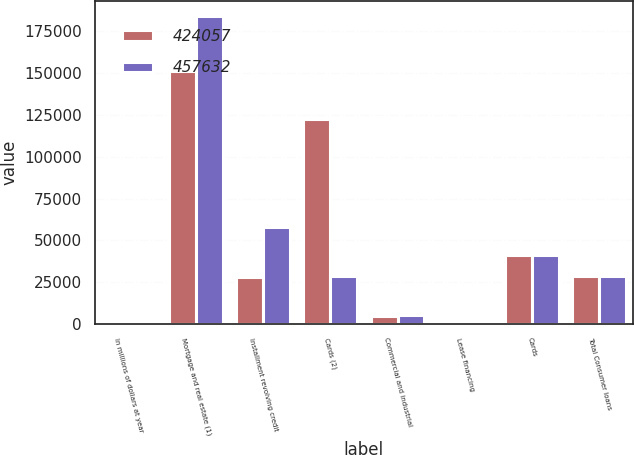Convert chart to OTSL. <chart><loc_0><loc_0><loc_500><loc_500><stacked_bar_chart><ecel><fcel>In millions of dollars at year<fcel>Mortgage and real estate (1)<fcel>Installment revolving credit<fcel>Cards (2)<fcel>Commercial and industrial<fcel>Lease financing<fcel>Cards<fcel>Total Consumer loans<nl><fcel>424057<fcel>2010<fcel>151469<fcel>28291<fcel>122384<fcel>5021<fcel>2<fcel>40948<fcel>28621<nl><fcel>457632<fcel>2009<fcel>183842<fcel>58099<fcel>28951<fcel>5640<fcel>11<fcel>41493<fcel>28621<nl></chart> 